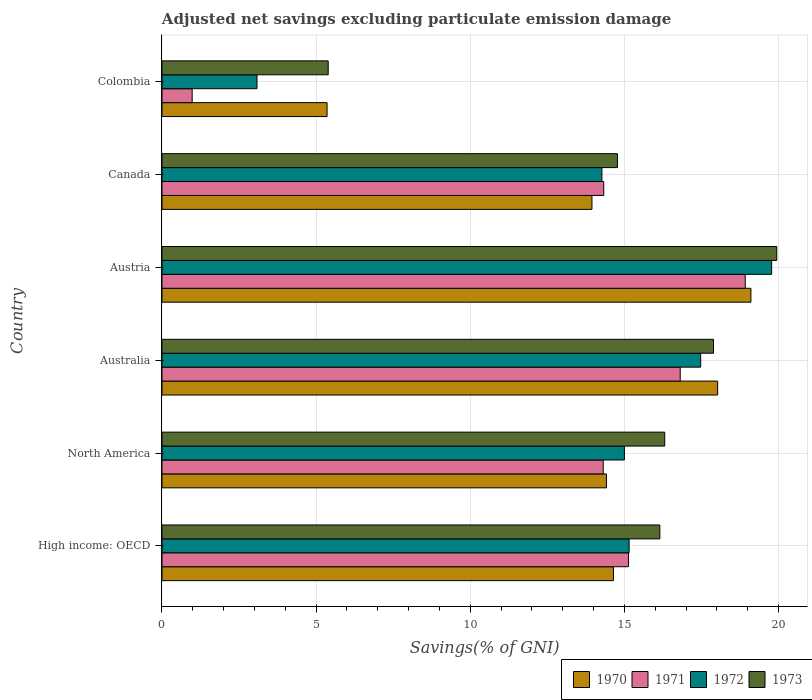Are the number of bars per tick equal to the number of legend labels?
Provide a succinct answer. Yes. Are the number of bars on each tick of the Y-axis equal?
Make the answer very short. Yes. How many bars are there on the 6th tick from the bottom?
Give a very brief answer. 4. What is the label of the 3rd group of bars from the top?
Make the answer very short. Austria. In how many cases, is the number of bars for a given country not equal to the number of legend labels?
Provide a succinct answer. 0. What is the adjusted net savings in 1973 in North America?
Give a very brief answer. 16.31. Across all countries, what is the maximum adjusted net savings in 1973?
Your answer should be compact. 19.94. Across all countries, what is the minimum adjusted net savings in 1970?
Provide a short and direct response. 5.36. In which country was the adjusted net savings in 1971 maximum?
Provide a succinct answer. Austria. What is the total adjusted net savings in 1971 in the graph?
Give a very brief answer. 80.49. What is the difference between the adjusted net savings in 1970 in Austria and that in Colombia?
Your response must be concise. 13.75. What is the difference between the adjusted net savings in 1972 in North America and the adjusted net savings in 1973 in High income: OECD?
Keep it short and to the point. -1.15. What is the average adjusted net savings in 1973 per country?
Ensure brevity in your answer.  15.08. What is the difference between the adjusted net savings in 1973 and adjusted net savings in 1970 in Austria?
Give a very brief answer. 0.84. What is the ratio of the adjusted net savings in 1971 in Australia to that in Colombia?
Make the answer very short. 17.17. What is the difference between the highest and the second highest adjusted net savings in 1971?
Your response must be concise. 2.11. What is the difference between the highest and the lowest adjusted net savings in 1972?
Make the answer very short. 16.7. Is the sum of the adjusted net savings in 1970 in High income: OECD and North America greater than the maximum adjusted net savings in 1973 across all countries?
Your response must be concise. Yes. What is the difference between two consecutive major ticks on the X-axis?
Your answer should be compact. 5. Does the graph contain any zero values?
Offer a very short reply. No. Does the graph contain grids?
Your response must be concise. Yes. How many legend labels are there?
Provide a succinct answer. 4. What is the title of the graph?
Provide a short and direct response. Adjusted net savings excluding particulate emission damage. What is the label or title of the X-axis?
Keep it short and to the point. Savings(% of GNI). What is the Savings(% of GNI) of 1970 in High income: OECD?
Your response must be concise. 14.65. What is the Savings(% of GNI) of 1971 in High income: OECD?
Offer a very short reply. 15.13. What is the Savings(% of GNI) in 1972 in High income: OECD?
Offer a terse response. 15.15. What is the Savings(% of GNI) in 1973 in High income: OECD?
Keep it short and to the point. 16.15. What is the Savings(% of GNI) in 1970 in North America?
Give a very brief answer. 14.42. What is the Savings(% of GNI) of 1971 in North America?
Give a very brief answer. 14.31. What is the Savings(% of GNI) in 1972 in North America?
Offer a very short reply. 15. What is the Savings(% of GNI) in 1973 in North America?
Offer a terse response. 16.31. What is the Savings(% of GNI) in 1970 in Australia?
Provide a short and direct response. 18.03. What is the Savings(% of GNI) in 1971 in Australia?
Offer a terse response. 16.81. What is the Savings(% of GNI) in 1972 in Australia?
Make the answer very short. 17.48. What is the Savings(% of GNI) in 1973 in Australia?
Provide a succinct answer. 17.89. What is the Savings(% of GNI) of 1970 in Austria?
Provide a short and direct response. 19.11. What is the Savings(% of GNI) in 1971 in Austria?
Your answer should be very brief. 18.92. What is the Savings(% of GNI) of 1972 in Austria?
Your answer should be compact. 19.78. What is the Savings(% of GNI) of 1973 in Austria?
Give a very brief answer. 19.94. What is the Savings(% of GNI) of 1970 in Canada?
Keep it short and to the point. 13.95. What is the Savings(% of GNI) of 1971 in Canada?
Offer a very short reply. 14.33. What is the Savings(% of GNI) of 1972 in Canada?
Offer a terse response. 14.27. What is the Savings(% of GNI) of 1973 in Canada?
Offer a terse response. 14.78. What is the Savings(% of GNI) of 1970 in Colombia?
Provide a short and direct response. 5.36. What is the Savings(% of GNI) in 1971 in Colombia?
Keep it short and to the point. 0.98. What is the Savings(% of GNI) of 1972 in Colombia?
Your answer should be compact. 3.08. What is the Savings(% of GNI) of 1973 in Colombia?
Your response must be concise. 5.39. Across all countries, what is the maximum Savings(% of GNI) in 1970?
Give a very brief answer. 19.11. Across all countries, what is the maximum Savings(% of GNI) in 1971?
Your response must be concise. 18.92. Across all countries, what is the maximum Savings(% of GNI) in 1972?
Ensure brevity in your answer.  19.78. Across all countries, what is the maximum Savings(% of GNI) of 1973?
Make the answer very short. 19.94. Across all countries, what is the minimum Savings(% of GNI) of 1970?
Offer a terse response. 5.36. Across all countries, what is the minimum Savings(% of GNI) of 1971?
Your answer should be very brief. 0.98. Across all countries, what is the minimum Savings(% of GNI) of 1972?
Keep it short and to the point. 3.08. Across all countries, what is the minimum Savings(% of GNI) in 1973?
Keep it short and to the point. 5.39. What is the total Savings(% of GNI) of 1970 in the graph?
Provide a short and direct response. 85.5. What is the total Savings(% of GNI) in 1971 in the graph?
Make the answer very short. 80.49. What is the total Savings(% of GNI) in 1972 in the graph?
Your answer should be compact. 84.77. What is the total Savings(% of GNI) of 1973 in the graph?
Offer a very short reply. 90.47. What is the difference between the Savings(% of GNI) in 1970 in High income: OECD and that in North America?
Make the answer very short. 0.23. What is the difference between the Savings(% of GNI) in 1971 in High income: OECD and that in North America?
Make the answer very short. 0.82. What is the difference between the Savings(% of GNI) in 1972 in High income: OECD and that in North America?
Provide a succinct answer. 0.15. What is the difference between the Savings(% of GNI) in 1973 in High income: OECD and that in North America?
Offer a very short reply. -0.16. What is the difference between the Savings(% of GNI) in 1970 in High income: OECD and that in Australia?
Give a very brief answer. -3.38. What is the difference between the Savings(% of GNI) in 1971 in High income: OECD and that in Australia?
Your answer should be very brief. -1.68. What is the difference between the Savings(% of GNI) of 1972 in High income: OECD and that in Australia?
Ensure brevity in your answer.  -2.32. What is the difference between the Savings(% of GNI) in 1973 in High income: OECD and that in Australia?
Your answer should be compact. -1.74. What is the difference between the Savings(% of GNI) in 1970 in High income: OECD and that in Austria?
Make the answer very short. -4.46. What is the difference between the Savings(% of GNI) of 1971 in High income: OECD and that in Austria?
Ensure brevity in your answer.  -3.79. What is the difference between the Savings(% of GNI) of 1972 in High income: OECD and that in Austria?
Offer a terse response. -4.62. What is the difference between the Savings(% of GNI) of 1973 in High income: OECD and that in Austria?
Keep it short and to the point. -3.79. What is the difference between the Savings(% of GNI) in 1970 in High income: OECD and that in Canada?
Your answer should be compact. 0.7. What is the difference between the Savings(% of GNI) in 1971 in High income: OECD and that in Canada?
Offer a very short reply. 0.8. What is the difference between the Savings(% of GNI) in 1972 in High income: OECD and that in Canada?
Your answer should be compact. 0.88. What is the difference between the Savings(% of GNI) of 1973 in High income: OECD and that in Canada?
Your response must be concise. 1.38. What is the difference between the Savings(% of GNI) in 1970 in High income: OECD and that in Colombia?
Provide a succinct answer. 9.29. What is the difference between the Savings(% of GNI) of 1971 in High income: OECD and that in Colombia?
Give a very brief answer. 14.15. What is the difference between the Savings(% of GNI) in 1972 in High income: OECD and that in Colombia?
Make the answer very short. 12.07. What is the difference between the Savings(% of GNI) in 1973 in High income: OECD and that in Colombia?
Keep it short and to the point. 10.76. What is the difference between the Savings(% of GNI) of 1970 in North America and that in Australia?
Provide a succinct answer. -3.61. What is the difference between the Savings(% of GNI) of 1971 in North America and that in Australia?
Provide a succinct answer. -2.5. What is the difference between the Savings(% of GNI) of 1972 in North America and that in Australia?
Your answer should be compact. -2.47. What is the difference between the Savings(% of GNI) in 1973 in North America and that in Australia?
Offer a terse response. -1.58. What is the difference between the Savings(% of GNI) of 1970 in North America and that in Austria?
Keep it short and to the point. -4.69. What is the difference between the Savings(% of GNI) of 1971 in North America and that in Austria?
Offer a very short reply. -4.61. What is the difference between the Savings(% of GNI) of 1972 in North America and that in Austria?
Give a very brief answer. -4.78. What is the difference between the Savings(% of GNI) in 1973 in North America and that in Austria?
Make the answer very short. -3.63. What is the difference between the Savings(% of GNI) of 1970 in North America and that in Canada?
Offer a very short reply. 0.47. What is the difference between the Savings(% of GNI) in 1971 in North America and that in Canada?
Make the answer very short. -0.02. What is the difference between the Savings(% of GNI) of 1972 in North America and that in Canada?
Make the answer very short. 0.73. What is the difference between the Savings(% of GNI) of 1973 in North America and that in Canada?
Keep it short and to the point. 1.53. What is the difference between the Savings(% of GNI) in 1970 in North America and that in Colombia?
Ensure brevity in your answer.  9.06. What is the difference between the Savings(% of GNI) in 1971 in North America and that in Colombia?
Ensure brevity in your answer.  13.34. What is the difference between the Savings(% of GNI) in 1972 in North America and that in Colombia?
Give a very brief answer. 11.92. What is the difference between the Savings(% of GNI) in 1973 in North America and that in Colombia?
Ensure brevity in your answer.  10.92. What is the difference between the Savings(% of GNI) in 1970 in Australia and that in Austria?
Your answer should be very brief. -1.08. What is the difference between the Savings(% of GNI) in 1971 in Australia and that in Austria?
Offer a terse response. -2.11. What is the difference between the Savings(% of GNI) in 1972 in Australia and that in Austria?
Your answer should be compact. -2.3. What is the difference between the Savings(% of GNI) in 1973 in Australia and that in Austria?
Give a very brief answer. -2.05. What is the difference between the Savings(% of GNI) in 1970 in Australia and that in Canada?
Keep it short and to the point. 4.08. What is the difference between the Savings(% of GNI) of 1971 in Australia and that in Canada?
Your answer should be very brief. 2.48. What is the difference between the Savings(% of GNI) in 1972 in Australia and that in Canada?
Offer a terse response. 3.2. What is the difference between the Savings(% of GNI) in 1973 in Australia and that in Canada?
Your response must be concise. 3.12. What is the difference between the Savings(% of GNI) in 1970 in Australia and that in Colombia?
Make the answer very short. 12.67. What is the difference between the Savings(% of GNI) of 1971 in Australia and that in Colombia?
Keep it short and to the point. 15.83. What is the difference between the Savings(% of GNI) of 1972 in Australia and that in Colombia?
Keep it short and to the point. 14.39. What is the difference between the Savings(% of GNI) in 1970 in Austria and that in Canada?
Offer a terse response. 5.16. What is the difference between the Savings(% of GNI) in 1971 in Austria and that in Canada?
Provide a succinct answer. 4.59. What is the difference between the Savings(% of GNI) of 1972 in Austria and that in Canada?
Provide a succinct answer. 5.51. What is the difference between the Savings(% of GNI) in 1973 in Austria and that in Canada?
Ensure brevity in your answer.  5.17. What is the difference between the Savings(% of GNI) in 1970 in Austria and that in Colombia?
Offer a terse response. 13.75. What is the difference between the Savings(% of GNI) in 1971 in Austria and that in Colombia?
Give a very brief answer. 17.94. What is the difference between the Savings(% of GNI) in 1972 in Austria and that in Colombia?
Make the answer very short. 16.7. What is the difference between the Savings(% of GNI) of 1973 in Austria and that in Colombia?
Your response must be concise. 14.55. What is the difference between the Savings(% of GNI) of 1970 in Canada and that in Colombia?
Make the answer very short. 8.59. What is the difference between the Savings(% of GNI) in 1971 in Canada and that in Colombia?
Keep it short and to the point. 13.35. What is the difference between the Savings(% of GNI) of 1972 in Canada and that in Colombia?
Provide a short and direct response. 11.19. What is the difference between the Savings(% of GNI) of 1973 in Canada and that in Colombia?
Your answer should be very brief. 9.38. What is the difference between the Savings(% of GNI) of 1970 in High income: OECD and the Savings(% of GNI) of 1971 in North America?
Your response must be concise. 0.33. What is the difference between the Savings(% of GNI) of 1970 in High income: OECD and the Savings(% of GNI) of 1972 in North America?
Give a very brief answer. -0.36. What is the difference between the Savings(% of GNI) of 1970 in High income: OECD and the Savings(% of GNI) of 1973 in North America?
Your answer should be very brief. -1.66. What is the difference between the Savings(% of GNI) of 1971 in High income: OECD and the Savings(% of GNI) of 1972 in North America?
Your answer should be compact. 0.13. What is the difference between the Savings(% of GNI) in 1971 in High income: OECD and the Savings(% of GNI) in 1973 in North America?
Provide a short and direct response. -1.18. What is the difference between the Savings(% of GNI) in 1972 in High income: OECD and the Savings(% of GNI) in 1973 in North America?
Provide a short and direct response. -1.15. What is the difference between the Savings(% of GNI) in 1970 in High income: OECD and the Savings(% of GNI) in 1971 in Australia?
Make the answer very short. -2.17. What is the difference between the Savings(% of GNI) of 1970 in High income: OECD and the Savings(% of GNI) of 1972 in Australia?
Give a very brief answer. -2.83. What is the difference between the Savings(% of GNI) of 1970 in High income: OECD and the Savings(% of GNI) of 1973 in Australia?
Your response must be concise. -3.25. What is the difference between the Savings(% of GNI) in 1971 in High income: OECD and the Savings(% of GNI) in 1972 in Australia?
Your answer should be compact. -2.34. What is the difference between the Savings(% of GNI) of 1971 in High income: OECD and the Savings(% of GNI) of 1973 in Australia?
Keep it short and to the point. -2.76. What is the difference between the Savings(% of GNI) in 1972 in High income: OECD and the Savings(% of GNI) in 1973 in Australia?
Make the answer very short. -2.74. What is the difference between the Savings(% of GNI) in 1970 in High income: OECD and the Savings(% of GNI) in 1971 in Austria?
Your response must be concise. -4.28. What is the difference between the Savings(% of GNI) in 1970 in High income: OECD and the Savings(% of GNI) in 1972 in Austria?
Offer a terse response. -5.13. What is the difference between the Savings(% of GNI) in 1970 in High income: OECD and the Savings(% of GNI) in 1973 in Austria?
Provide a short and direct response. -5.3. What is the difference between the Savings(% of GNI) of 1971 in High income: OECD and the Savings(% of GNI) of 1972 in Austria?
Provide a succinct answer. -4.64. What is the difference between the Savings(% of GNI) in 1971 in High income: OECD and the Savings(% of GNI) in 1973 in Austria?
Provide a succinct answer. -4.81. What is the difference between the Savings(% of GNI) of 1972 in High income: OECD and the Savings(% of GNI) of 1973 in Austria?
Give a very brief answer. -4.79. What is the difference between the Savings(% of GNI) in 1970 in High income: OECD and the Savings(% of GNI) in 1971 in Canada?
Your response must be concise. 0.32. What is the difference between the Savings(% of GNI) of 1970 in High income: OECD and the Savings(% of GNI) of 1972 in Canada?
Offer a very short reply. 0.37. What is the difference between the Savings(% of GNI) of 1970 in High income: OECD and the Savings(% of GNI) of 1973 in Canada?
Your response must be concise. -0.13. What is the difference between the Savings(% of GNI) in 1971 in High income: OECD and the Savings(% of GNI) in 1972 in Canada?
Give a very brief answer. 0.86. What is the difference between the Savings(% of GNI) in 1971 in High income: OECD and the Savings(% of GNI) in 1973 in Canada?
Provide a short and direct response. 0.36. What is the difference between the Savings(% of GNI) of 1972 in High income: OECD and the Savings(% of GNI) of 1973 in Canada?
Ensure brevity in your answer.  0.38. What is the difference between the Savings(% of GNI) of 1970 in High income: OECD and the Savings(% of GNI) of 1971 in Colombia?
Provide a succinct answer. 13.67. What is the difference between the Savings(% of GNI) of 1970 in High income: OECD and the Savings(% of GNI) of 1972 in Colombia?
Provide a short and direct response. 11.56. What is the difference between the Savings(% of GNI) of 1970 in High income: OECD and the Savings(% of GNI) of 1973 in Colombia?
Offer a terse response. 9.25. What is the difference between the Savings(% of GNI) in 1971 in High income: OECD and the Savings(% of GNI) in 1972 in Colombia?
Provide a short and direct response. 12.05. What is the difference between the Savings(% of GNI) in 1971 in High income: OECD and the Savings(% of GNI) in 1973 in Colombia?
Your response must be concise. 9.74. What is the difference between the Savings(% of GNI) in 1972 in High income: OECD and the Savings(% of GNI) in 1973 in Colombia?
Your answer should be very brief. 9.76. What is the difference between the Savings(% of GNI) of 1970 in North America and the Savings(% of GNI) of 1971 in Australia?
Provide a succinct answer. -2.39. What is the difference between the Savings(% of GNI) in 1970 in North America and the Savings(% of GNI) in 1972 in Australia?
Give a very brief answer. -3.06. What is the difference between the Savings(% of GNI) of 1970 in North America and the Savings(% of GNI) of 1973 in Australia?
Make the answer very short. -3.47. What is the difference between the Savings(% of GNI) of 1971 in North America and the Savings(% of GNI) of 1972 in Australia?
Provide a succinct answer. -3.16. What is the difference between the Savings(% of GNI) in 1971 in North America and the Savings(% of GNI) in 1973 in Australia?
Offer a very short reply. -3.58. What is the difference between the Savings(% of GNI) in 1972 in North America and the Savings(% of GNI) in 1973 in Australia?
Give a very brief answer. -2.89. What is the difference between the Savings(% of GNI) of 1970 in North America and the Savings(% of GNI) of 1971 in Austria?
Your response must be concise. -4.5. What is the difference between the Savings(% of GNI) in 1970 in North America and the Savings(% of GNI) in 1972 in Austria?
Make the answer very short. -5.36. What is the difference between the Savings(% of GNI) in 1970 in North America and the Savings(% of GNI) in 1973 in Austria?
Offer a very short reply. -5.52. What is the difference between the Savings(% of GNI) in 1971 in North America and the Savings(% of GNI) in 1972 in Austria?
Your answer should be compact. -5.46. What is the difference between the Savings(% of GNI) of 1971 in North America and the Savings(% of GNI) of 1973 in Austria?
Offer a terse response. -5.63. What is the difference between the Savings(% of GNI) in 1972 in North America and the Savings(% of GNI) in 1973 in Austria?
Your answer should be compact. -4.94. What is the difference between the Savings(% of GNI) of 1970 in North America and the Savings(% of GNI) of 1971 in Canada?
Offer a terse response. 0.09. What is the difference between the Savings(% of GNI) in 1970 in North America and the Savings(% of GNI) in 1972 in Canada?
Your answer should be compact. 0.15. What is the difference between the Savings(% of GNI) in 1970 in North America and the Savings(% of GNI) in 1973 in Canada?
Provide a short and direct response. -0.36. What is the difference between the Savings(% of GNI) of 1971 in North America and the Savings(% of GNI) of 1972 in Canada?
Offer a terse response. 0.04. What is the difference between the Savings(% of GNI) of 1971 in North America and the Savings(% of GNI) of 1973 in Canada?
Provide a short and direct response. -0.46. What is the difference between the Savings(% of GNI) in 1972 in North America and the Savings(% of GNI) in 1973 in Canada?
Offer a very short reply. 0.23. What is the difference between the Savings(% of GNI) of 1970 in North America and the Savings(% of GNI) of 1971 in Colombia?
Make the answer very short. 13.44. What is the difference between the Savings(% of GNI) of 1970 in North America and the Savings(% of GNI) of 1972 in Colombia?
Your answer should be compact. 11.34. What is the difference between the Savings(% of GNI) of 1970 in North America and the Savings(% of GNI) of 1973 in Colombia?
Make the answer very short. 9.03. What is the difference between the Savings(% of GNI) in 1971 in North America and the Savings(% of GNI) in 1972 in Colombia?
Your answer should be compact. 11.23. What is the difference between the Savings(% of GNI) of 1971 in North America and the Savings(% of GNI) of 1973 in Colombia?
Offer a terse response. 8.92. What is the difference between the Savings(% of GNI) of 1972 in North America and the Savings(% of GNI) of 1973 in Colombia?
Your answer should be very brief. 9.61. What is the difference between the Savings(% of GNI) in 1970 in Australia and the Savings(% of GNI) in 1971 in Austria?
Provide a succinct answer. -0.9. What is the difference between the Savings(% of GNI) of 1970 in Australia and the Savings(% of GNI) of 1972 in Austria?
Provide a succinct answer. -1.75. What is the difference between the Savings(% of GNI) of 1970 in Australia and the Savings(% of GNI) of 1973 in Austria?
Provide a short and direct response. -1.92. What is the difference between the Savings(% of GNI) of 1971 in Australia and the Savings(% of GNI) of 1972 in Austria?
Give a very brief answer. -2.97. What is the difference between the Savings(% of GNI) in 1971 in Australia and the Savings(% of GNI) in 1973 in Austria?
Ensure brevity in your answer.  -3.13. What is the difference between the Savings(% of GNI) in 1972 in Australia and the Savings(% of GNI) in 1973 in Austria?
Provide a succinct answer. -2.47. What is the difference between the Savings(% of GNI) in 1970 in Australia and the Savings(% of GNI) in 1971 in Canada?
Ensure brevity in your answer.  3.7. What is the difference between the Savings(% of GNI) of 1970 in Australia and the Savings(% of GNI) of 1972 in Canada?
Keep it short and to the point. 3.75. What is the difference between the Savings(% of GNI) of 1970 in Australia and the Savings(% of GNI) of 1973 in Canada?
Make the answer very short. 3.25. What is the difference between the Savings(% of GNI) in 1971 in Australia and the Savings(% of GNI) in 1972 in Canada?
Your response must be concise. 2.54. What is the difference between the Savings(% of GNI) in 1971 in Australia and the Savings(% of GNI) in 1973 in Canada?
Your answer should be compact. 2.04. What is the difference between the Savings(% of GNI) in 1970 in Australia and the Savings(% of GNI) in 1971 in Colombia?
Ensure brevity in your answer.  17.05. What is the difference between the Savings(% of GNI) of 1970 in Australia and the Savings(% of GNI) of 1972 in Colombia?
Give a very brief answer. 14.94. What is the difference between the Savings(% of GNI) in 1970 in Australia and the Savings(% of GNI) in 1973 in Colombia?
Your answer should be very brief. 12.63. What is the difference between the Savings(% of GNI) in 1971 in Australia and the Savings(% of GNI) in 1972 in Colombia?
Offer a terse response. 13.73. What is the difference between the Savings(% of GNI) of 1971 in Australia and the Savings(% of GNI) of 1973 in Colombia?
Make the answer very short. 11.42. What is the difference between the Savings(% of GNI) in 1972 in Australia and the Savings(% of GNI) in 1973 in Colombia?
Keep it short and to the point. 12.08. What is the difference between the Savings(% of GNI) in 1970 in Austria and the Savings(% of GNI) in 1971 in Canada?
Provide a short and direct response. 4.77. What is the difference between the Savings(% of GNI) in 1970 in Austria and the Savings(% of GNI) in 1972 in Canada?
Keep it short and to the point. 4.83. What is the difference between the Savings(% of GNI) of 1970 in Austria and the Savings(% of GNI) of 1973 in Canada?
Offer a very short reply. 4.33. What is the difference between the Savings(% of GNI) in 1971 in Austria and the Savings(% of GNI) in 1972 in Canada?
Provide a succinct answer. 4.65. What is the difference between the Savings(% of GNI) in 1971 in Austria and the Savings(% of GNI) in 1973 in Canada?
Make the answer very short. 4.15. What is the difference between the Savings(% of GNI) of 1972 in Austria and the Savings(% of GNI) of 1973 in Canada?
Make the answer very short. 5. What is the difference between the Savings(% of GNI) in 1970 in Austria and the Savings(% of GNI) in 1971 in Colombia?
Offer a very short reply. 18.13. What is the difference between the Savings(% of GNI) of 1970 in Austria and the Savings(% of GNI) of 1972 in Colombia?
Offer a terse response. 16.02. What is the difference between the Savings(% of GNI) of 1970 in Austria and the Savings(% of GNI) of 1973 in Colombia?
Offer a very short reply. 13.71. What is the difference between the Savings(% of GNI) of 1971 in Austria and the Savings(% of GNI) of 1972 in Colombia?
Your answer should be compact. 15.84. What is the difference between the Savings(% of GNI) of 1971 in Austria and the Savings(% of GNI) of 1973 in Colombia?
Offer a terse response. 13.53. What is the difference between the Savings(% of GNI) in 1972 in Austria and the Savings(% of GNI) in 1973 in Colombia?
Offer a terse response. 14.39. What is the difference between the Savings(% of GNI) of 1970 in Canada and the Savings(% of GNI) of 1971 in Colombia?
Make the answer very short. 12.97. What is the difference between the Savings(% of GNI) of 1970 in Canada and the Savings(% of GNI) of 1972 in Colombia?
Offer a very short reply. 10.87. What is the difference between the Savings(% of GNI) in 1970 in Canada and the Savings(% of GNI) in 1973 in Colombia?
Make the answer very short. 8.56. What is the difference between the Savings(% of GNI) in 1971 in Canada and the Savings(% of GNI) in 1972 in Colombia?
Give a very brief answer. 11.25. What is the difference between the Savings(% of GNI) in 1971 in Canada and the Savings(% of GNI) in 1973 in Colombia?
Give a very brief answer. 8.94. What is the difference between the Savings(% of GNI) of 1972 in Canada and the Savings(% of GNI) of 1973 in Colombia?
Your answer should be compact. 8.88. What is the average Savings(% of GNI) of 1970 per country?
Offer a very short reply. 14.25. What is the average Savings(% of GNI) in 1971 per country?
Your answer should be compact. 13.42. What is the average Savings(% of GNI) in 1972 per country?
Provide a succinct answer. 14.13. What is the average Savings(% of GNI) in 1973 per country?
Provide a short and direct response. 15.08. What is the difference between the Savings(% of GNI) in 1970 and Savings(% of GNI) in 1971 in High income: OECD?
Your answer should be very brief. -0.49. What is the difference between the Savings(% of GNI) of 1970 and Savings(% of GNI) of 1972 in High income: OECD?
Give a very brief answer. -0.51. What is the difference between the Savings(% of GNI) of 1970 and Savings(% of GNI) of 1973 in High income: OECD?
Make the answer very short. -1.51. What is the difference between the Savings(% of GNI) in 1971 and Savings(% of GNI) in 1972 in High income: OECD?
Your answer should be very brief. -0.02. What is the difference between the Savings(% of GNI) in 1971 and Savings(% of GNI) in 1973 in High income: OECD?
Offer a very short reply. -1.02. What is the difference between the Savings(% of GNI) of 1972 and Savings(% of GNI) of 1973 in High income: OECD?
Ensure brevity in your answer.  -1. What is the difference between the Savings(% of GNI) in 1970 and Savings(% of GNI) in 1971 in North America?
Ensure brevity in your answer.  0.11. What is the difference between the Savings(% of GNI) of 1970 and Savings(% of GNI) of 1972 in North America?
Offer a very short reply. -0.58. What is the difference between the Savings(% of GNI) of 1970 and Savings(% of GNI) of 1973 in North America?
Give a very brief answer. -1.89. What is the difference between the Savings(% of GNI) in 1971 and Savings(% of GNI) in 1972 in North America?
Provide a succinct answer. -0.69. What is the difference between the Savings(% of GNI) in 1971 and Savings(% of GNI) in 1973 in North America?
Your response must be concise. -2. What is the difference between the Savings(% of GNI) of 1972 and Savings(% of GNI) of 1973 in North America?
Your answer should be very brief. -1.31. What is the difference between the Savings(% of GNI) in 1970 and Savings(% of GNI) in 1971 in Australia?
Your response must be concise. 1.21. What is the difference between the Savings(% of GNI) of 1970 and Savings(% of GNI) of 1972 in Australia?
Make the answer very short. 0.55. What is the difference between the Savings(% of GNI) in 1970 and Savings(% of GNI) in 1973 in Australia?
Make the answer very short. 0.13. What is the difference between the Savings(% of GNI) in 1971 and Savings(% of GNI) in 1972 in Australia?
Provide a succinct answer. -0.66. What is the difference between the Savings(% of GNI) in 1971 and Savings(% of GNI) in 1973 in Australia?
Keep it short and to the point. -1.08. What is the difference between the Savings(% of GNI) in 1972 and Savings(% of GNI) in 1973 in Australia?
Give a very brief answer. -0.42. What is the difference between the Savings(% of GNI) in 1970 and Savings(% of GNI) in 1971 in Austria?
Keep it short and to the point. 0.18. What is the difference between the Savings(% of GNI) of 1970 and Savings(% of GNI) of 1972 in Austria?
Provide a short and direct response. -0.67. What is the difference between the Savings(% of GNI) in 1970 and Savings(% of GNI) in 1973 in Austria?
Your response must be concise. -0.84. What is the difference between the Savings(% of GNI) in 1971 and Savings(% of GNI) in 1972 in Austria?
Provide a succinct answer. -0.86. What is the difference between the Savings(% of GNI) in 1971 and Savings(% of GNI) in 1973 in Austria?
Give a very brief answer. -1.02. What is the difference between the Savings(% of GNI) of 1972 and Savings(% of GNI) of 1973 in Austria?
Your answer should be very brief. -0.17. What is the difference between the Savings(% of GNI) of 1970 and Savings(% of GNI) of 1971 in Canada?
Your answer should be compact. -0.38. What is the difference between the Savings(% of GNI) in 1970 and Savings(% of GNI) in 1972 in Canada?
Offer a terse response. -0.32. What is the difference between the Savings(% of GNI) in 1970 and Savings(% of GNI) in 1973 in Canada?
Offer a very short reply. -0.83. What is the difference between the Savings(% of GNI) in 1971 and Savings(% of GNI) in 1972 in Canada?
Your response must be concise. 0.06. What is the difference between the Savings(% of GNI) of 1971 and Savings(% of GNI) of 1973 in Canada?
Keep it short and to the point. -0.45. What is the difference between the Savings(% of GNI) of 1972 and Savings(% of GNI) of 1973 in Canada?
Give a very brief answer. -0.5. What is the difference between the Savings(% of GNI) of 1970 and Savings(% of GNI) of 1971 in Colombia?
Your answer should be very brief. 4.38. What is the difference between the Savings(% of GNI) of 1970 and Savings(% of GNI) of 1972 in Colombia?
Offer a very short reply. 2.27. What is the difference between the Savings(% of GNI) of 1970 and Savings(% of GNI) of 1973 in Colombia?
Your response must be concise. -0.04. What is the difference between the Savings(% of GNI) in 1971 and Savings(% of GNI) in 1972 in Colombia?
Offer a terse response. -2.1. What is the difference between the Savings(% of GNI) in 1971 and Savings(% of GNI) in 1973 in Colombia?
Offer a very short reply. -4.41. What is the difference between the Savings(% of GNI) in 1972 and Savings(% of GNI) in 1973 in Colombia?
Your answer should be compact. -2.31. What is the ratio of the Savings(% of GNI) in 1970 in High income: OECD to that in North America?
Keep it short and to the point. 1.02. What is the ratio of the Savings(% of GNI) of 1971 in High income: OECD to that in North America?
Give a very brief answer. 1.06. What is the ratio of the Savings(% of GNI) of 1972 in High income: OECD to that in North America?
Your answer should be very brief. 1.01. What is the ratio of the Savings(% of GNI) of 1973 in High income: OECD to that in North America?
Your response must be concise. 0.99. What is the ratio of the Savings(% of GNI) of 1970 in High income: OECD to that in Australia?
Keep it short and to the point. 0.81. What is the ratio of the Savings(% of GNI) in 1971 in High income: OECD to that in Australia?
Offer a very short reply. 0.9. What is the ratio of the Savings(% of GNI) of 1972 in High income: OECD to that in Australia?
Offer a very short reply. 0.87. What is the ratio of the Savings(% of GNI) of 1973 in High income: OECD to that in Australia?
Your answer should be compact. 0.9. What is the ratio of the Savings(% of GNI) of 1970 in High income: OECD to that in Austria?
Your answer should be compact. 0.77. What is the ratio of the Savings(% of GNI) of 1971 in High income: OECD to that in Austria?
Give a very brief answer. 0.8. What is the ratio of the Savings(% of GNI) in 1972 in High income: OECD to that in Austria?
Your answer should be compact. 0.77. What is the ratio of the Savings(% of GNI) in 1973 in High income: OECD to that in Austria?
Provide a short and direct response. 0.81. What is the ratio of the Savings(% of GNI) of 1970 in High income: OECD to that in Canada?
Offer a very short reply. 1.05. What is the ratio of the Savings(% of GNI) in 1971 in High income: OECD to that in Canada?
Offer a terse response. 1.06. What is the ratio of the Savings(% of GNI) of 1972 in High income: OECD to that in Canada?
Offer a very short reply. 1.06. What is the ratio of the Savings(% of GNI) of 1973 in High income: OECD to that in Canada?
Your answer should be very brief. 1.09. What is the ratio of the Savings(% of GNI) in 1970 in High income: OECD to that in Colombia?
Keep it short and to the point. 2.73. What is the ratio of the Savings(% of GNI) of 1971 in High income: OECD to that in Colombia?
Your answer should be compact. 15.45. What is the ratio of the Savings(% of GNI) in 1972 in High income: OECD to that in Colombia?
Keep it short and to the point. 4.92. What is the ratio of the Savings(% of GNI) in 1973 in High income: OECD to that in Colombia?
Your response must be concise. 3. What is the ratio of the Savings(% of GNI) in 1970 in North America to that in Australia?
Offer a very short reply. 0.8. What is the ratio of the Savings(% of GNI) in 1971 in North America to that in Australia?
Ensure brevity in your answer.  0.85. What is the ratio of the Savings(% of GNI) of 1972 in North America to that in Australia?
Give a very brief answer. 0.86. What is the ratio of the Savings(% of GNI) in 1973 in North America to that in Australia?
Your answer should be compact. 0.91. What is the ratio of the Savings(% of GNI) in 1970 in North America to that in Austria?
Keep it short and to the point. 0.75. What is the ratio of the Savings(% of GNI) of 1971 in North America to that in Austria?
Offer a very short reply. 0.76. What is the ratio of the Savings(% of GNI) in 1972 in North America to that in Austria?
Your response must be concise. 0.76. What is the ratio of the Savings(% of GNI) in 1973 in North America to that in Austria?
Your answer should be very brief. 0.82. What is the ratio of the Savings(% of GNI) in 1970 in North America to that in Canada?
Your answer should be very brief. 1.03. What is the ratio of the Savings(% of GNI) in 1972 in North America to that in Canada?
Offer a terse response. 1.05. What is the ratio of the Savings(% of GNI) in 1973 in North America to that in Canada?
Give a very brief answer. 1.1. What is the ratio of the Savings(% of GNI) of 1970 in North America to that in Colombia?
Your response must be concise. 2.69. What is the ratio of the Savings(% of GNI) of 1971 in North America to that in Colombia?
Provide a succinct answer. 14.62. What is the ratio of the Savings(% of GNI) in 1972 in North America to that in Colombia?
Ensure brevity in your answer.  4.87. What is the ratio of the Savings(% of GNI) in 1973 in North America to that in Colombia?
Your answer should be very brief. 3.02. What is the ratio of the Savings(% of GNI) in 1970 in Australia to that in Austria?
Ensure brevity in your answer.  0.94. What is the ratio of the Savings(% of GNI) in 1971 in Australia to that in Austria?
Keep it short and to the point. 0.89. What is the ratio of the Savings(% of GNI) of 1972 in Australia to that in Austria?
Offer a terse response. 0.88. What is the ratio of the Savings(% of GNI) in 1973 in Australia to that in Austria?
Make the answer very short. 0.9. What is the ratio of the Savings(% of GNI) in 1970 in Australia to that in Canada?
Keep it short and to the point. 1.29. What is the ratio of the Savings(% of GNI) in 1971 in Australia to that in Canada?
Provide a short and direct response. 1.17. What is the ratio of the Savings(% of GNI) in 1972 in Australia to that in Canada?
Your answer should be compact. 1.22. What is the ratio of the Savings(% of GNI) of 1973 in Australia to that in Canada?
Your answer should be very brief. 1.21. What is the ratio of the Savings(% of GNI) of 1970 in Australia to that in Colombia?
Make the answer very short. 3.37. What is the ratio of the Savings(% of GNI) of 1971 in Australia to that in Colombia?
Your response must be concise. 17.17. What is the ratio of the Savings(% of GNI) of 1972 in Australia to that in Colombia?
Your answer should be very brief. 5.67. What is the ratio of the Savings(% of GNI) in 1973 in Australia to that in Colombia?
Your answer should be very brief. 3.32. What is the ratio of the Savings(% of GNI) in 1970 in Austria to that in Canada?
Provide a succinct answer. 1.37. What is the ratio of the Savings(% of GNI) of 1971 in Austria to that in Canada?
Your answer should be very brief. 1.32. What is the ratio of the Savings(% of GNI) in 1972 in Austria to that in Canada?
Keep it short and to the point. 1.39. What is the ratio of the Savings(% of GNI) of 1973 in Austria to that in Canada?
Your response must be concise. 1.35. What is the ratio of the Savings(% of GNI) in 1970 in Austria to that in Colombia?
Keep it short and to the point. 3.57. What is the ratio of the Savings(% of GNI) of 1971 in Austria to that in Colombia?
Offer a terse response. 19.32. What is the ratio of the Savings(% of GNI) of 1972 in Austria to that in Colombia?
Your answer should be compact. 6.42. What is the ratio of the Savings(% of GNI) of 1973 in Austria to that in Colombia?
Give a very brief answer. 3.7. What is the ratio of the Savings(% of GNI) of 1970 in Canada to that in Colombia?
Give a very brief answer. 2.6. What is the ratio of the Savings(% of GNI) in 1971 in Canada to that in Colombia?
Your response must be concise. 14.64. What is the ratio of the Savings(% of GNI) in 1972 in Canada to that in Colombia?
Your answer should be compact. 4.63. What is the ratio of the Savings(% of GNI) in 1973 in Canada to that in Colombia?
Give a very brief answer. 2.74. What is the difference between the highest and the second highest Savings(% of GNI) of 1970?
Provide a short and direct response. 1.08. What is the difference between the highest and the second highest Savings(% of GNI) in 1971?
Ensure brevity in your answer.  2.11. What is the difference between the highest and the second highest Savings(% of GNI) of 1972?
Your response must be concise. 2.3. What is the difference between the highest and the second highest Savings(% of GNI) of 1973?
Your response must be concise. 2.05. What is the difference between the highest and the lowest Savings(% of GNI) in 1970?
Your response must be concise. 13.75. What is the difference between the highest and the lowest Savings(% of GNI) of 1971?
Ensure brevity in your answer.  17.94. What is the difference between the highest and the lowest Savings(% of GNI) in 1972?
Provide a succinct answer. 16.7. What is the difference between the highest and the lowest Savings(% of GNI) of 1973?
Your answer should be very brief. 14.55. 